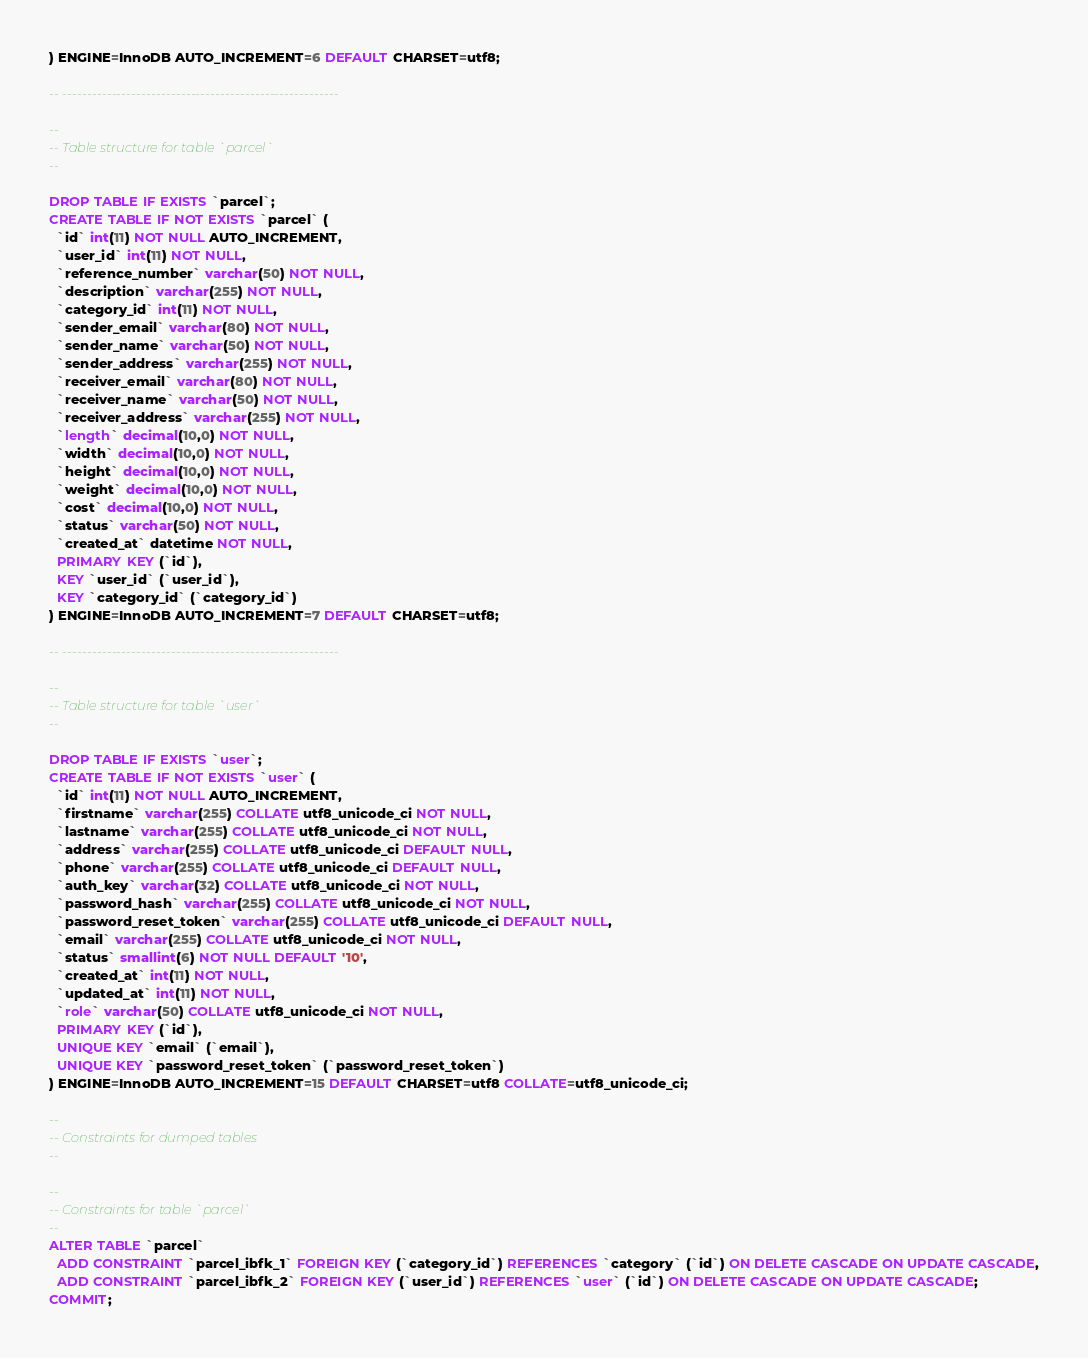Convert code to text. <code><loc_0><loc_0><loc_500><loc_500><_SQL_>) ENGINE=InnoDB AUTO_INCREMENT=6 DEFAULT CHARSET=utf8;

-- --------------------------------------------------------

--
-- Table structure for table `parcel`
--

DROP TABLE IF EXISTS `parcel`;
CREATE TABLE IF NOT EXISTS `parcel` (
  `id` int(11) NOT NULL AUTO_INCREMENT,
  `user_id` int(11) NOT NULL,
  `reference_number` varchar(50) NOT NULL,
  `description` varchar(255) NOT NULL,
  `category_id` int(11) NOT NULL,
  `sender_email` varchar(80) NOT NULL,
  `sender_name` varchar(50) NOT NULL,
  `sender_address` varchar(255) NOT NULL,
  `receiver_email` varchar(80) NOT NULL,
  `receiver_name` varchar(50) NOT NULL,
  `receiver_address` varchar(255) NOT NULL,
  `length` decimal(10,0) NOT NULL,
  `width` decimal(10,0) NOT NULL,
  `height` decimal(10,0) NOT NULL,
  `weight` decimal(10,0) NOT NULL,
  `cost` decimal(10,0) NOT NULL,
  `status` varchar(50) NOT NULL,
  `created_at` datetime NOT NULL,
  PRIMARY KEY (`id`),
  KEY `user_id` (`user_id`),
  KEY `category_id` (`category_id`)
) ENGINE=InnoDB AUTO_INCREMENT=7 DEFAULT CHARSET=utf8;

-- --------------------------------------------------------

--
-- Table structure for table `user`
--

DROP TABLE IF EXISTS `user`;
CREATE TABLE IF NOT EXISTS `user` (
  `id` int(11) NOT NULL AUTO_INCREMENT,
  `firstname` varchar(255) COLLATE utf8_unicode_ci NOT NULL,
  `lastname` varchar(255) COLLATE utf8_unicode_ci NOT NULL,
  `address` varchar(255) COLLATE utf8_unicode_ci DEFAULT NULL,
  `phone` varchar(255) COLLATE utf8_unicode_ci DEFAULT NULL,
  `auth_key` varchar(32) COLLATE utf8_unicode_ci NOT NULL,
  `password_hash` varchar(255) COLLATE utf8_unicode_ci NOT NULL,
  `password_reset_token` varchar(255) COLLATE utf8_unicode_ci DEFAULT NULL,
  `email` varchar(255) COLLATE utf8_unicode_ci NOT NULL,
  `status` smallint(6) NOT NULL DEFAULT '10',
  `created_at` int(11) NOT NULL,
  `updated_at` int(11) NOT NULL,
  `role` varchar(50) COLLATE utf8_unicode_ci NOT NULL,
  PRIMARY KEY (`id`),
  UNIQUE KEY `email` (`email`),
  UNIQUE KEY `password_reset_token` (`password_reset_token`)
) ENGINE=InnoDB AUTO_INCREMENT=15 DEFAULT CHARSET=utf8 COLLATE=utf8_unicode_ci;

--
-- Constraints for dumped tables
--

--
-- Constraints for table `parcel`
--
ALTER TABLE `parcel`
  ADD CONSTRAINT `parcel_ibfk_1` FOREIGN KEY (`category_id`) REFERENCES `category` (`id`) ON DELETE CASCADE ON UPDATE CASCADE,
  ADD CONSTRAINT `parcel_ibfk_2` FOREIGN KEY (`user_id`) REFERENCES `user` (`id`) ON DELETE CASCADE ON UPDATE CASCADE;
COMMIT;
</code> 